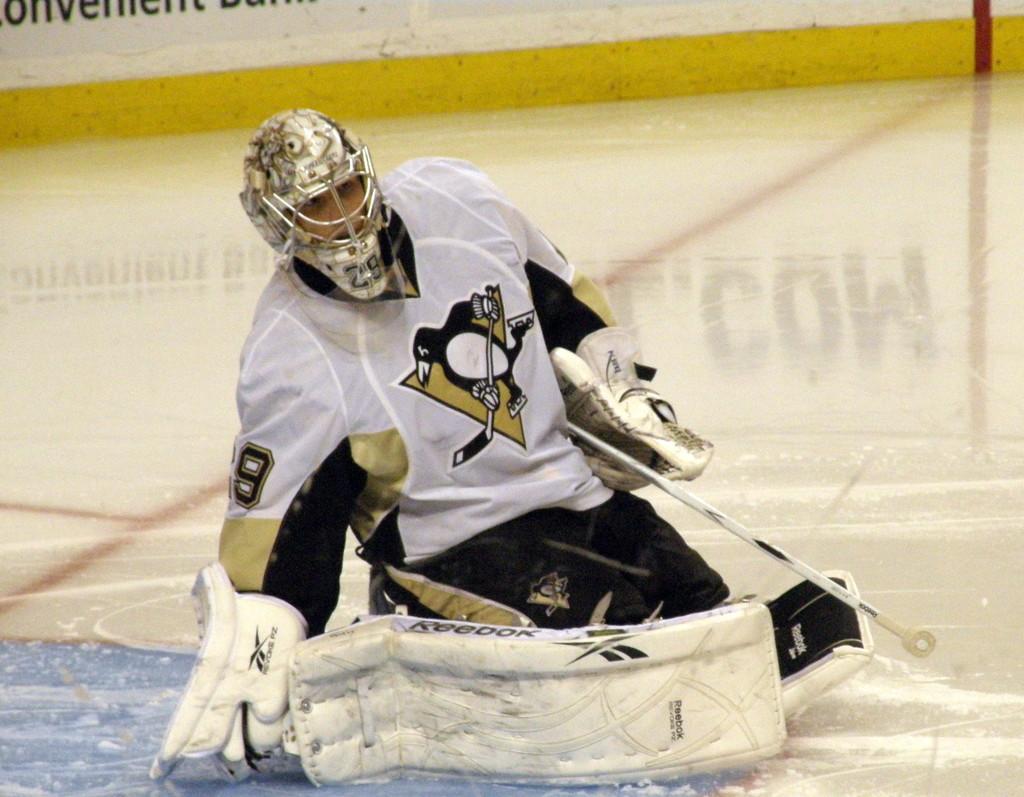Could you give a brief overview of what you see in this image? In this picture there is a man who is wearing helmet, gloves, jacket, trouser, pants and shoes. He is holding a bat. He is in a squat position. In the back there is a banner which is placed on the wall. 